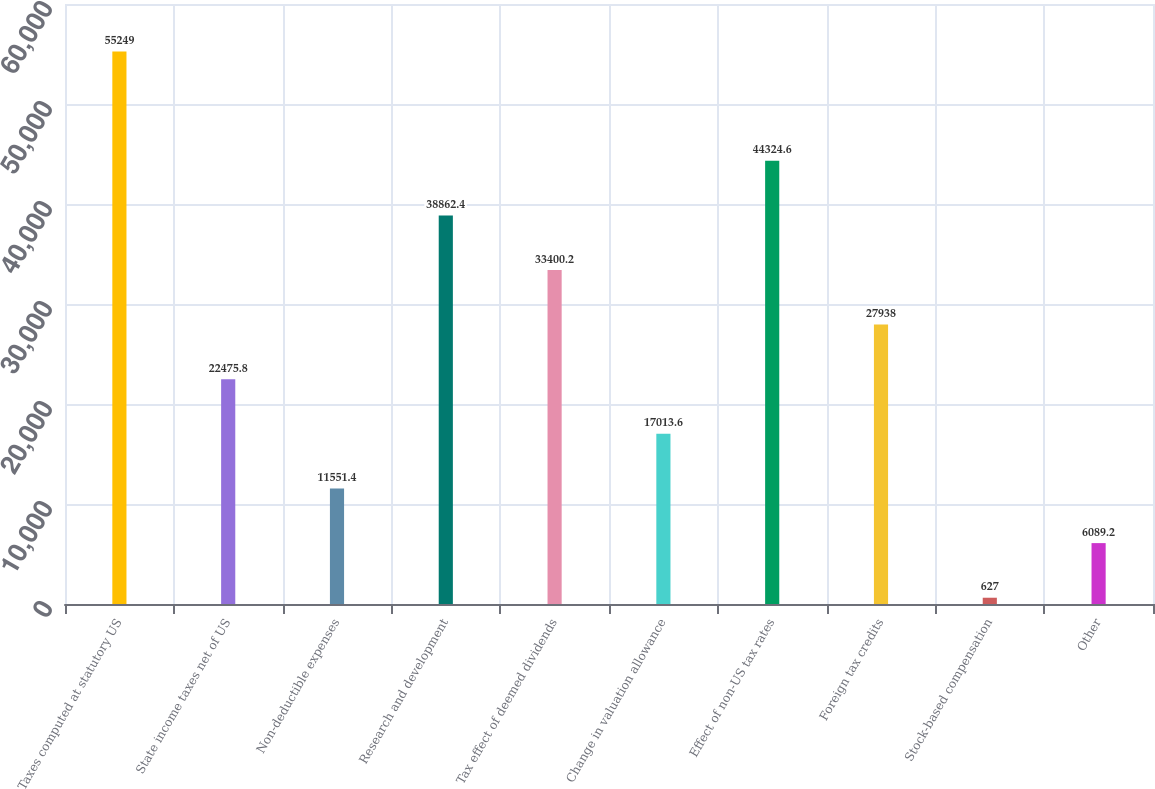<chart> <loc_0><loc_0><loc_500><loc_500><bar_chart><fcel>Taxes computed at statutory US<fcel>State income taxes net of US<fcel>Non-deductible expenses<fcel>Research and development<fcel>Tax effect of deemed dividends<fcel>Change in valuation allowance<fcel>Effect of non-US tax rates<fcel>Foreign tax credits<fcel>Stock-based compensation<fcel>Other<nl><fcel>55249<fcel>22475.8<fcel>11551.4<fcel>38862.4<fcel>33400.2<fcel>17013.6<fcel>44324.6<fcel>27938<fcel>627<fcel>6089.2<nl></chart> 